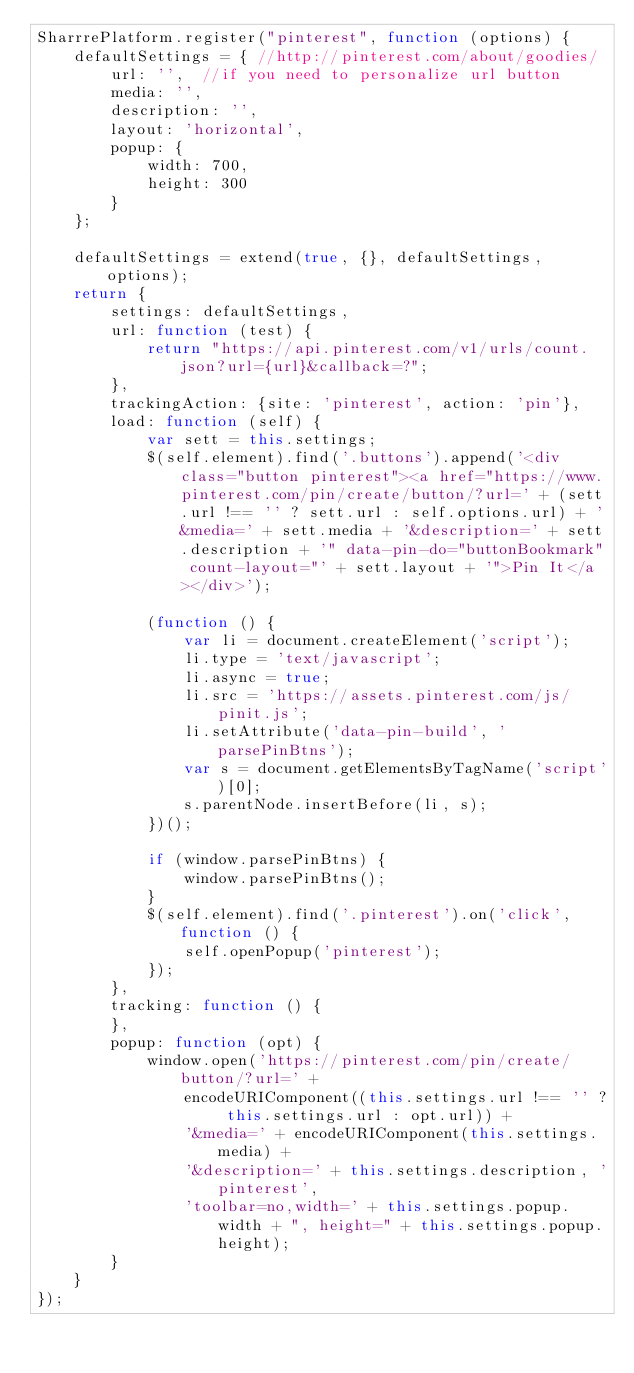Convert code to text. <code><loc_0><loc_0><loc_500><loc_500><_JavaScript_>SharrrePlatform.register("pinterest", function (options) {
    defaultSettings = { //http://pinterest.com/about/goodies/
        url: '',  //if you need to personalize url button
        media: '',
        description: '',
        layout: 'horizontal',
        popup: {
            width: 700,
            height: 300
        }
    };

    defaultSettings = extend(true, {}, defaultSettings, options);
    return {
        settings: defaultSettings,
        url: function (test) {
            return "https://api.pinterest.com/v1/urls/count.json?url={url}&callback=?";
        },
        trackingAction: {site: 'pinterest', action: 'pin'},
        load: function (self) {
            var sett = this.settings;
            $(self.element).find('.buttons').append('<div class="button pinterest"><a href="https://www.pinterest.com/pin/create/button/?url=' + (sett.url !== '' ? sett.url : self.options.url) + '&media=' + sett.media + '&description=' + sett.description + '" data-pin-do="buttonBookmark" count-layout="' + sett.layout + '">Pin It</a></div>');

            (function () {
                var li = document.createElement('script');
                li.type = 'text/javascript';
                li.async = true;
                li.src = 'https://assets.pinterest.com/js/pinit.js';
                li.setAttribute('data-pin-build', 'parsePinBtns');
                var s = document.getElementsByTagName('script')[0];
                s.parentNode.insertBefore(li, s);
            })();

            if (window.parsePinBtns) {
                window.parsePinBtns();
            }
            $(self.element).find('.pinterest').on('click', function () {
                self.openPopup('pinterest');
            });
        },
        tracking: function () {
        },
        popup: function (opt) {
            window.open('https://pinterest.com/pin/create/button/?url=' +
                encodeURIComponent((this.settings.url !== '' ? this.settings.url : opt.url)) +
                '&media=' + encodeURIComponent(this.settings.media) +
                '&description=' + this.settings.description, 'pinterest',
                'toolbar=no,width=' + this.settings.popup.width + ", height=" + this.settings.popup.height);
        }
    }
});</code> 